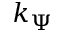Convert formula to latex. <formula><loc_0><loc_0><loc_500><loc_500>k _ { \Psi }</formula> 